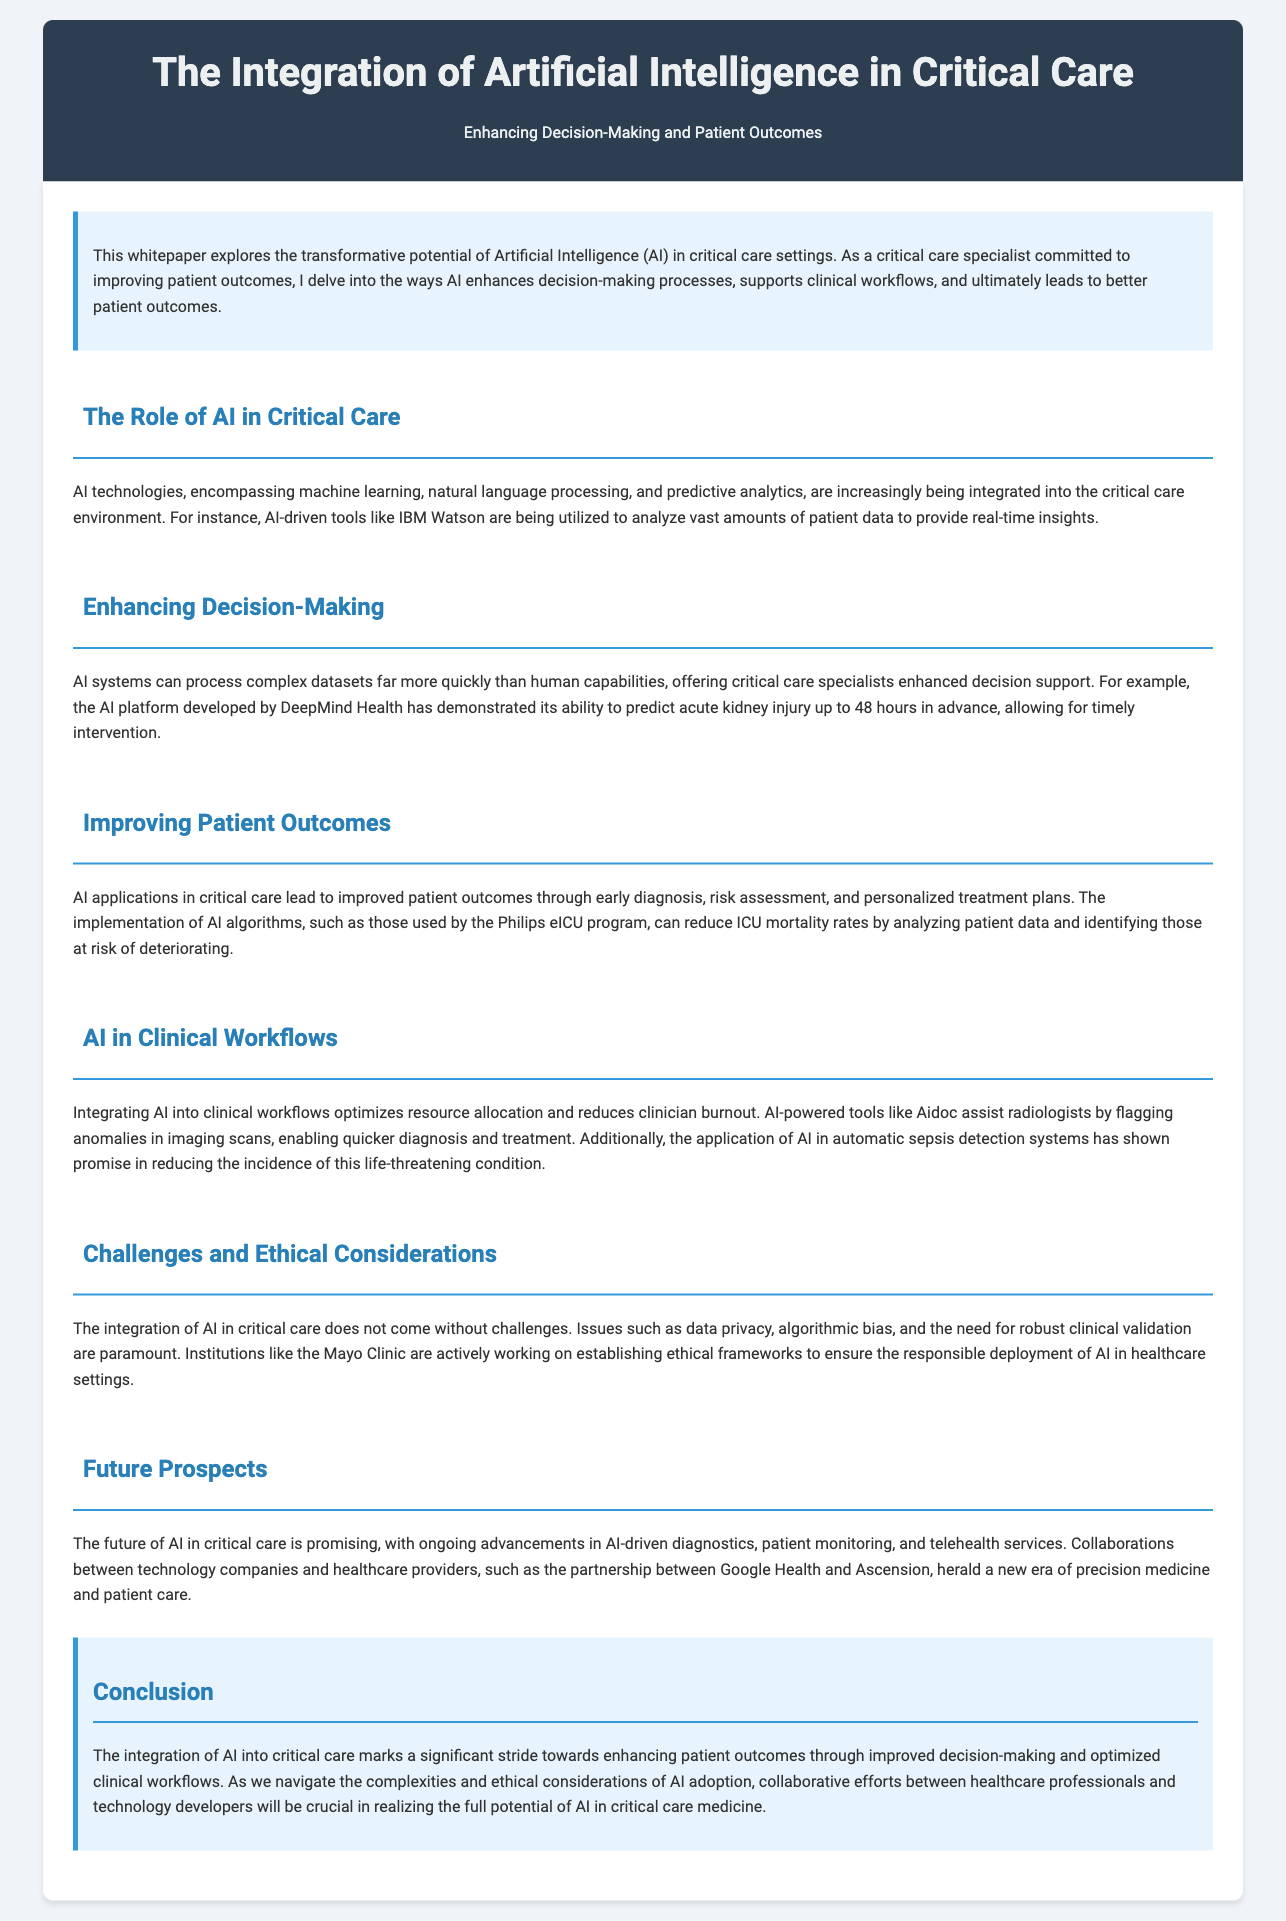What is the title of the whitepaper? The title of the whitepaper is displayed at the top of the document.
Answer: The Integration of Artificial Intelligence in Critical Care What technology is used for predictive analytics in critical care? The document mentions specific AI technologies within the content.
Answer: Predictive analytics Which organization developed the platform to predict acute kidney injury? The document references a specific AI platform by name associated with a prominent organization.
Answer: DeepMind Health How much can AI-driven tools like IBM Watson analyze? The document states that AI can analyze vast amounts of data in critical care.
Answer: Vast amounts What effect does AI have on ICU mortality rates according to the Philips eICU program? The document provides a specific outcome related to AI intervention in ICUs.
Answer: Reduce ICU mortality rates What challenges accompany the integration of AI in critical care? The document outlines various challenges that must be addressed for AI implementation.
Answer: Data privacy, algorithmic bias What is the partnership mentioned for advancing AI in healthcare? The document highlights a collaboration between two entities aimed at improving AI applications in healthcare.
Answer: Google Health and Ascension What is the main focus of the whitepaper? The introduction summarizes the primary aim of the document.
Answer: Enhancing decision-making and patient outcomes What type of workflow does AI integration aim to optimize? The document specifies the workflows being improved through AI technologies.
Answer: Clinical workflows 